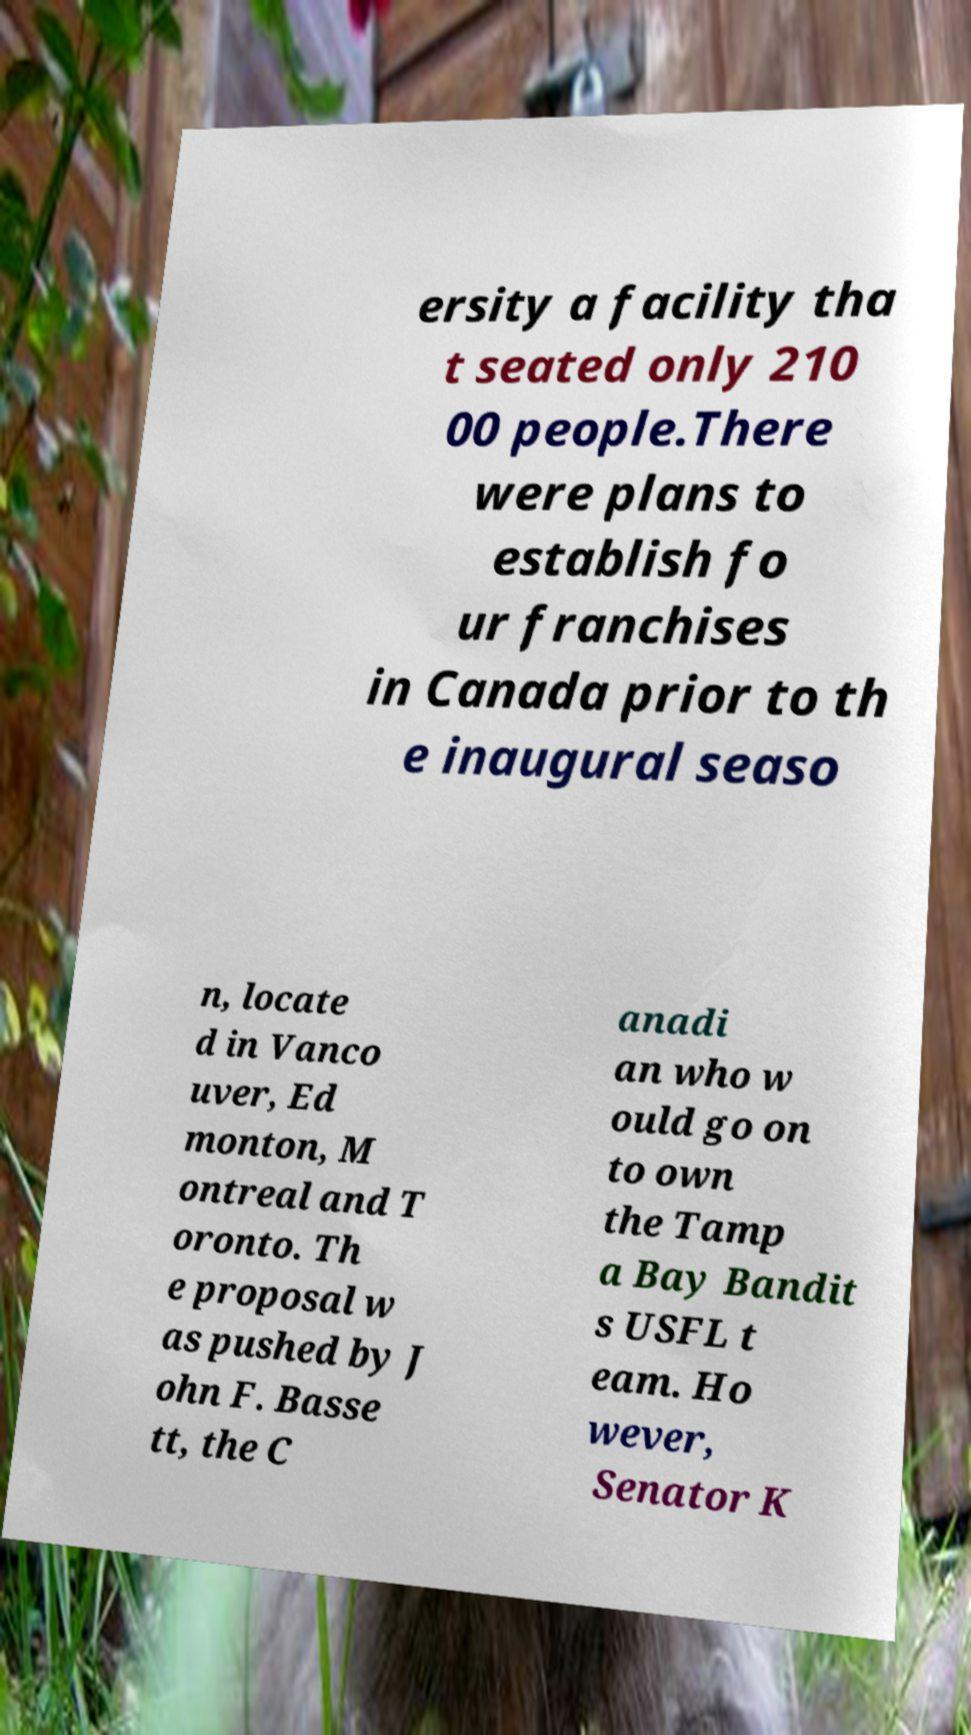I need the written content from this picture converted into text. Can you do that? ersity a facility tha t seated only 210 00 people.There were plans to establish fo ur franchises in Canada prior to th e inaugural seaso n, locate d in Vanco uver, Ed monton, M ontreal and T oronto. Th e proposal w as pushed by J ohn F. Basse tt, the C anadi an who w ould go on to own the Tamp a Bay Bandit s USFL t eam. Ho wever, Senator K 